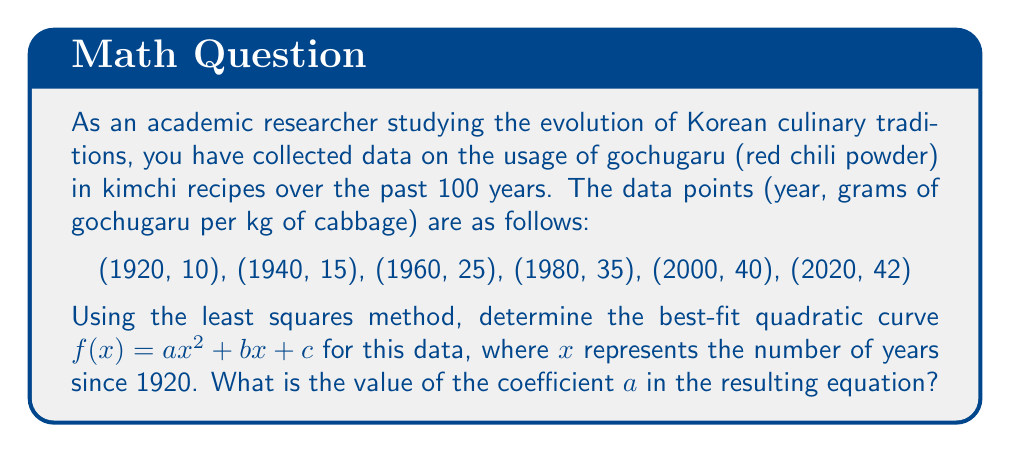Provide a solution to this math problem. To find the best-fit quadratic curve using the least squares method, we need to solve a system of normal equations. Let's follow these steps:

1) First, we need to transform our years to $x$ values representing years since 1920:
   (0, 10), (20, 15), (40, 25), (60, 35), (80, 40), (100, 42)

2) We need to calculate the following sums:
   $\sum x^4$, $\sum x^3$, $\sum x^2$, $\sum x$, $\sum y$, $\sum x^2y$, $\sum xy$

   $\sum x^4 = 0^4 + 20^4 + 40^4 + 60^4 + 80^4 + 100^4 = 23,920,000$
   $\sum x^3 = 0^3 + 20^3 + 40^3 + 60^3 + 80^3 + 100^3 = 1,640,000$
   $\sum x^2 = 0^2 + 20^2 + 40^2 + 60^2 + 80^2 + 100^2 = 70,000$
   $\sum x = 0 + 20 + 40 + 60 + 80 + 100 = 300$
   $\sum y = 10 + 15 + 25 + 35 + 40 + 42 = 167$
   $\sum x^2y = 0^2(10) + 20^2(15) + 40^2(25) + 60^2(35) + 80^2(40) + 100^2(42) = 834,000$
   $\sum xy = 0(10) + 20(15) + 40(25) + 60(35) + 80(40) + 100(42) = 11,300$

3) Now we can set up the normal equations:

   $$\begin{cases}
   a\sum x^4 + b\sum x^3 + c\sum x^2 = \sum x^2y \\
   a\sum x^3 + b\sum x^2 + c\sum x = \sum xy \\
   a\sum x^2 + b\sum x + cn = \sum y
   \end{cases}$$

   Where $n = 6$ (number of data points)

4) Substituting our calculated values:

   $$\begin{cases}
   23,920,000a + 1,640,000b + 70,000c = 834,000 \\
   1,640,000a + 70,000b + 300c = 11,300 \\
   70,000a + 300b + 6c = 167
   \end{cases}$$

5) Solving this system of equations (you can use a calculator or computer algebra system for this step), we get:

   $a = -0.00135$
   $b = 0.3585$
   $c = 9.715$

Therefore, the best-fit quadratic curve is:
$f(x) = -0.00135x^2 + 0.3585x + 9.715$

The question asks for the value of coefficient $a$, which is $-0.00135$.
Answer: $-0.00135$ 